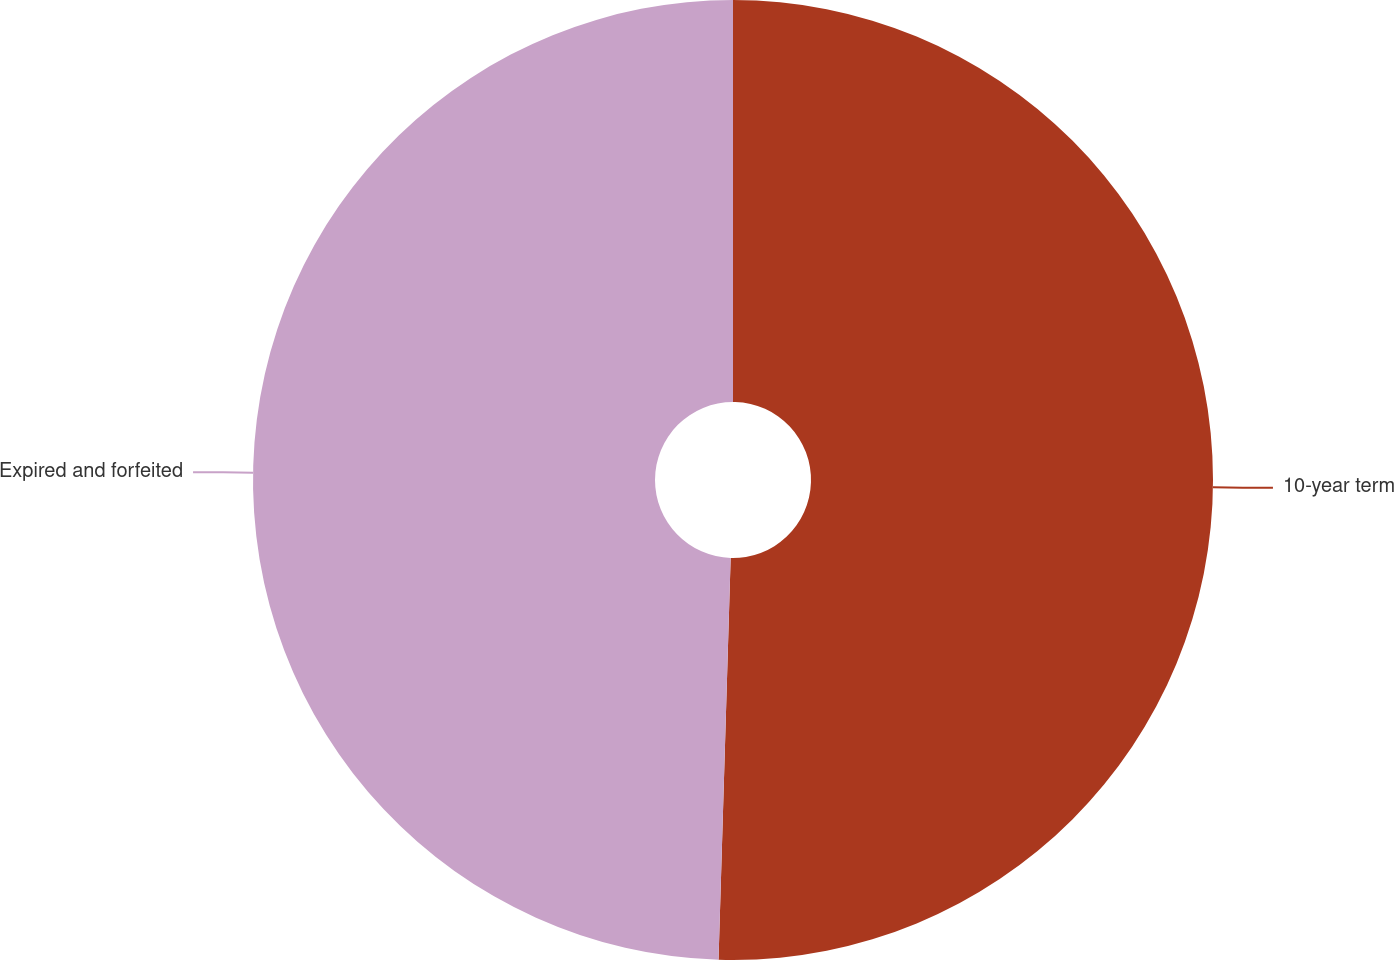Convert chart to OTSL. <chart><loc_0><loc_0><loc_500><loc_500><pie_chart><fcel>10-year term<fcel>Expired and forfeited<nl><fcel>50.48%<fcel>49.52%<nl></chart> 